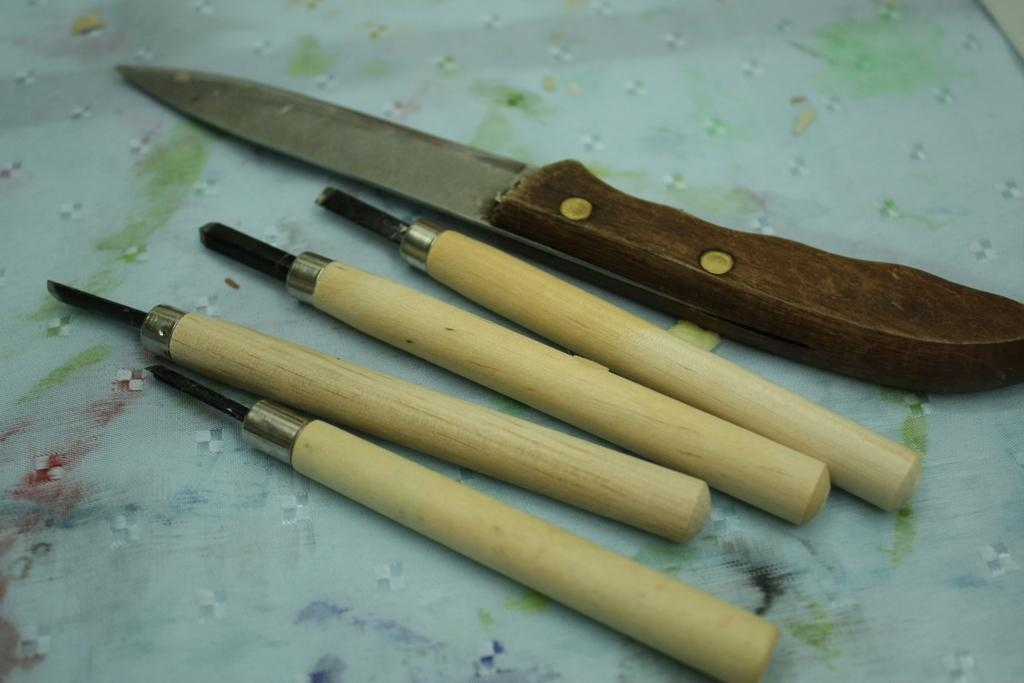What type of object can be seen in the image? There is a knife in the image. Are there any other objects related to the knife in the image? Yes, there are other tools in the image. Where are the tools placed in the image? The tools are placed on a surface that resembles a tablecloth. What type of thread is being used to sew the knife in the image? There is no thread or sewing activity depicted in the image; it only shows a knife and other tools placed on a surface. 